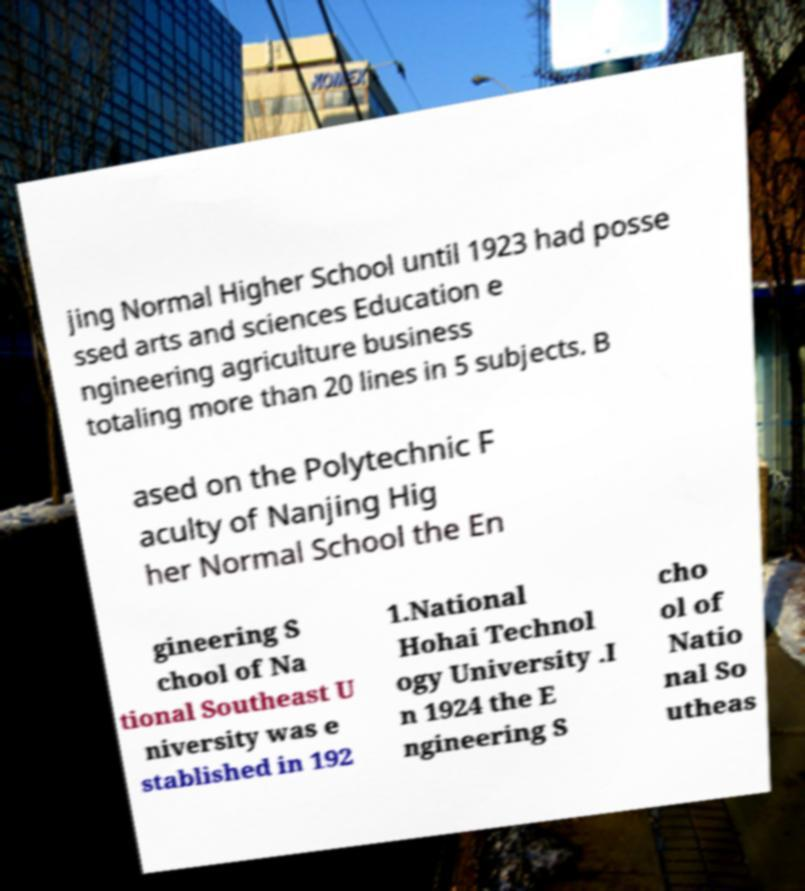Please identify and transcribe the text found in this image. jing Normal Higher School until 1923 had posse ssed arts and sciences Education e ngineering agriculture business totaling more than 20 lines in 5 subjects. B ased on the Polytechnic F aculty of Nanjing Hig her Normal School the En gineering S chool of Na tional Southeast U niversity was e stablished in 192 1.National Hohai Technol ogy University .I n 1924 the E ngineering S cho ol of Natio nal So utheas 